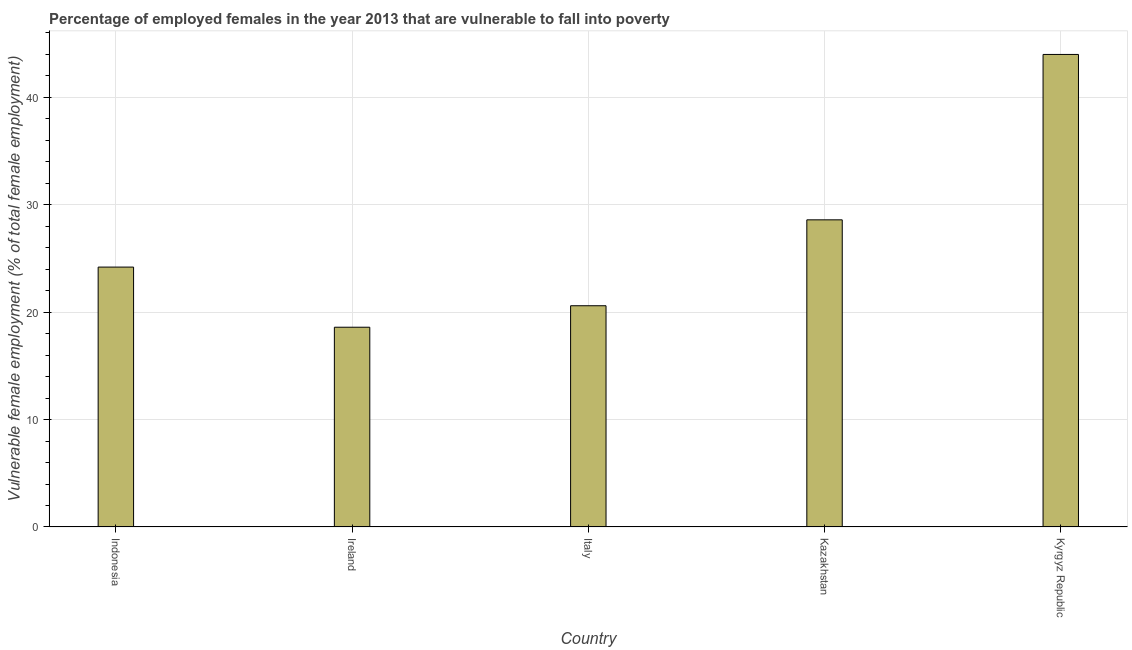Does the graph contain grids?
Make the answer very short. Yes. What is the title of the graph?
Provide a short and direct response. Percentage of employed females in the year 2013 that are vulnerable to fall into poverty. What is the label or title of the X-axis?
Keep it short and to the point. Country. What is the label or title of the Y-axis?
Ensure brevity in your answer.  Vulnerable female employment (% of total female employment). What is the percentage of employed females who are vulnerable to fall into poverty in Italy?
Your answer should be very brief. 20.6. Across all countries, what is the maximum percentage of employed females who are vulnerable to fall into poverty?
Offer a terse response. 44. Across all countries, what is the minimum percentage of employed females who are vulnerable to fall into poverty?
Provide a succinct answer. 18.6. In which country was the percentage of employed females who are vulnerable to fall into poverty maximum?
Ensure brevity in your answer.  Kyrgyz Republic. In which country was the percentage of employed females who are vulnerable to fall into poverty minimum?
Provide a succinct answer. Ireland. What is the sum of the percentage of employed females who are vulnerable to fall into poverty?
Your answer should be compact. 136. What is the average percentage of employed females who are vulnerable to fall into poverty per country?
Keep it short and to the point. 27.2. What is the median percentage of employed females who are vulnerable to fall into poverty?
Give a very brief answer. 24.2. In how many countries, is the percentage of employed females who are vulnerable to fall into poverty greater than 8 %?
Offer a terse response. 5. What is the ratio of the percentage of employed females who are vulnerable to fall into poverty in Ireland to that in Kyrgyz Republic?
Your answer should be compact. 0.42. What is the difference between the highest and the second highest percentage of employed females who are vulnerable to fall into poverty?
Give a very brief answer. 15.4. Is the sum of the percentage of employed females who are vulnerable to fall into poverty in Indonesia and Ireland greater than the maximum percentage of employed females who are vulnerable to fall into poverty across all countries?
Provide a succinct answer. No. What is the difference between the highest and the lowest percentage of employed females who are vulnerable to fall into poverty?
Your answer should be compact. 25.4. In how many countries, is the percentage of employed females who are vulnerable to fall into poverty greater than the average percentage of employed females who are vulnerable to fall into poverty taken over all countries?
Offer a very short reply. 2. How many bars are there?
Give a very brief answer. 5. Are all the bars in the graph horizontal?
Offer a terse response. No. What is the Vulnerable female employment (% of total female employment) of Indonesia?
Make the answer very short. 24.2. What is the Vulnerable female employment (% of total female employment) of Ireland?
Provide a short and direct response. 18.6. What is the Vulnerable female employment (% of total female employment) in Italy?
Ensure brevity in your answer.  20.6. What is the Vulnerable female employment (% of total female employment) in Kazakhstan?
Your response must be concise. 28.6. What is the difference between the Vulnerable female employment (% of total female employment) in Indonesia and Ireland?
Your answer should be very brief. 5.6. What is the difference between the Vulnerable female employment (% of total female employment) in Indonesia and Italy?
Make the answer very short. 3.6. What is the difference between the Vulnerable female employment (% of total female employment) in Indonesia and Kyrgyz Republic?
Offer a terse response. -19.8. What is the difference between the Vulnerable female employment (% of total female employment) in Ireland and Italy?
Offer a very short reply. -2. What is the difference between the Vulnerable female employment (% of total female employment) in Ireland and Kyrgyz Republic?
Your response must be concise. -25.4. What is the difference between the Vulnerable female employment (% of total female employment) in Italy and Kyrgyz Republic?
Give a very brief answer. -23.4. What is the difference between the Vulnerable female employment (% of total female employment) in Kazakhstan and Kyrgyz Republic?
Offer a terse response. -15.4. What is the ratio of the Vulnerable female employment (% of total female employment) in Indonesia to that in Ireland?
Provide a succinct answer. 1.3. What is the ratio of the Vulnerable female employment (% of total female employment) in Indonesia to that in Italy?
Make the answer very short. 1.18. What is the ratio of the Vulnerable female employment (% of total female employment) in Indonesia to that in Kazakhstan?
Offer a terse response. 0.85. What is the ratio of the Vulnerable female employment (% of total female employment) in Indonesia to that in Kyrgyz Republic?
Give a very brief answer. 0.55. What is the ratio of the Vulnerable female employment (% of total female employment) in Ireland to that in Italy?
Provide a short and direct response. 0.9. What is the ratio of the Vulnerable female employment (% of total female employment) in Ireland to that in Kazakhstan?
Offer a terse response. 0.65. What is the ratio of the Vulnerable female employment (% of total female employment) in Ireland to that in Kyrgyz Republic?
Ensure brevity in your answer.  0.42. What is the ratio of the Vulnerable female employment (% of total female employment) in Italy to that in Kazakhstan?
Provide a succinct answer. 0.72. What is the ratio of the Vulnerable female employment (% of total female employment) in Italy to that in Kyrgyz Republic?
Your answer should be very brief. 0.47. What is the ratio of the Vulnerable female employment (% of total female employment) in Kazakhstan to that in Kyrgyz Republic?
Keep it short and to the point. 0.65. 